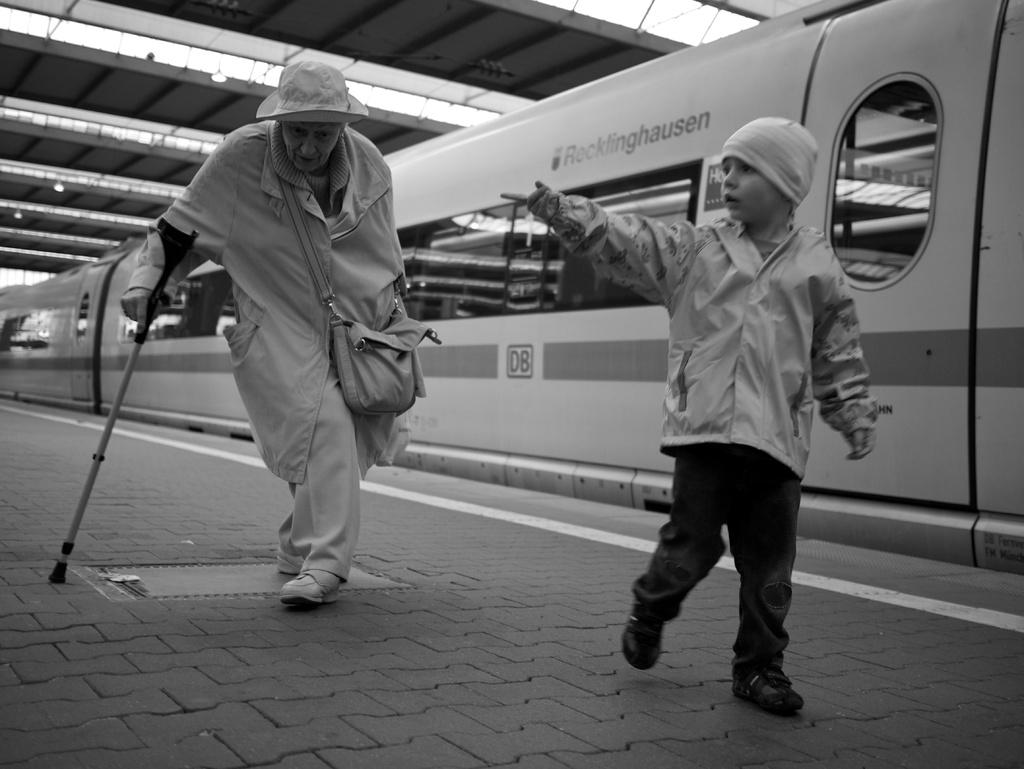Provide a one-sentence caption for the provided image. A train that says ROCKFINDHAUSEN ON IT.A boy pointing his finger. 